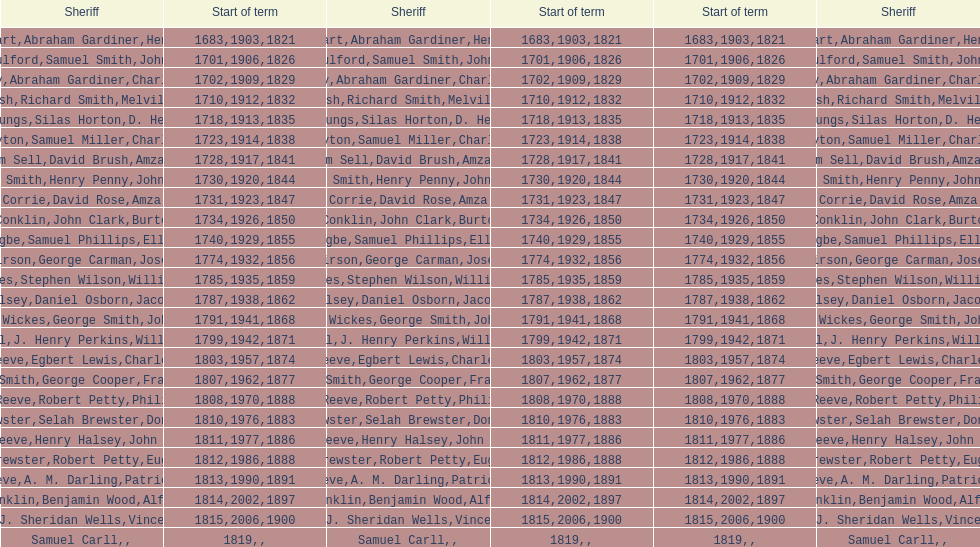How many sheriff's have the last name biggs? 1. 